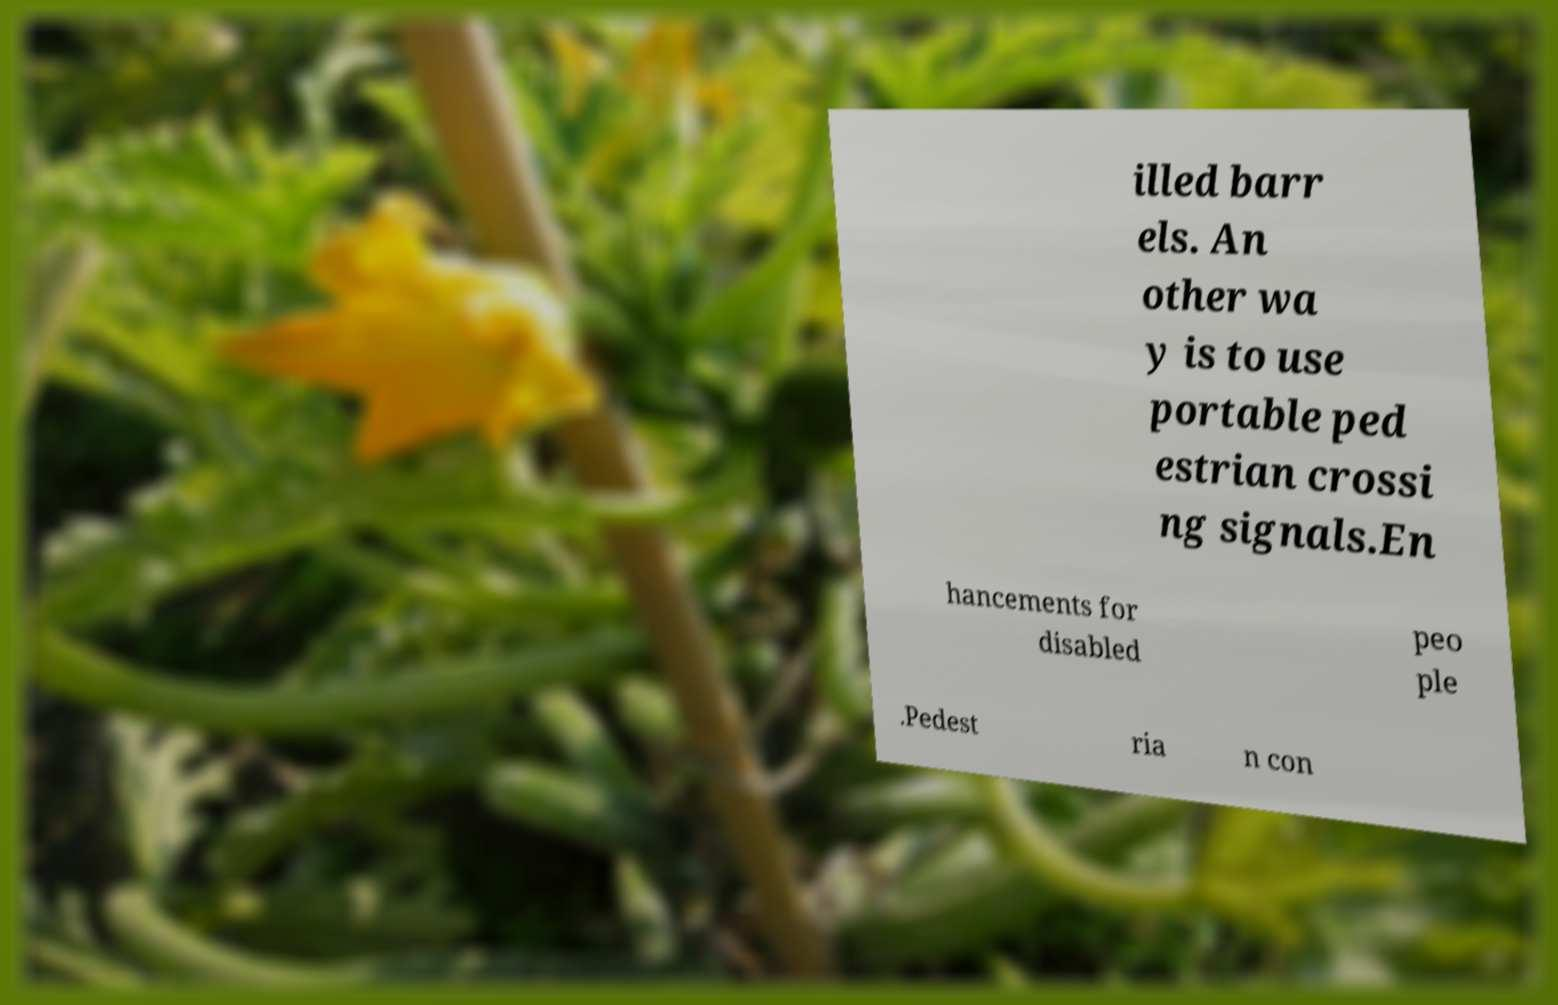Can you accurately transcribe the text from the provided image for me? illed barr els. An other wa y is to use portable ped estrian crossi ng signals.En hancements for disabled peo ple .Pedest ria n con 